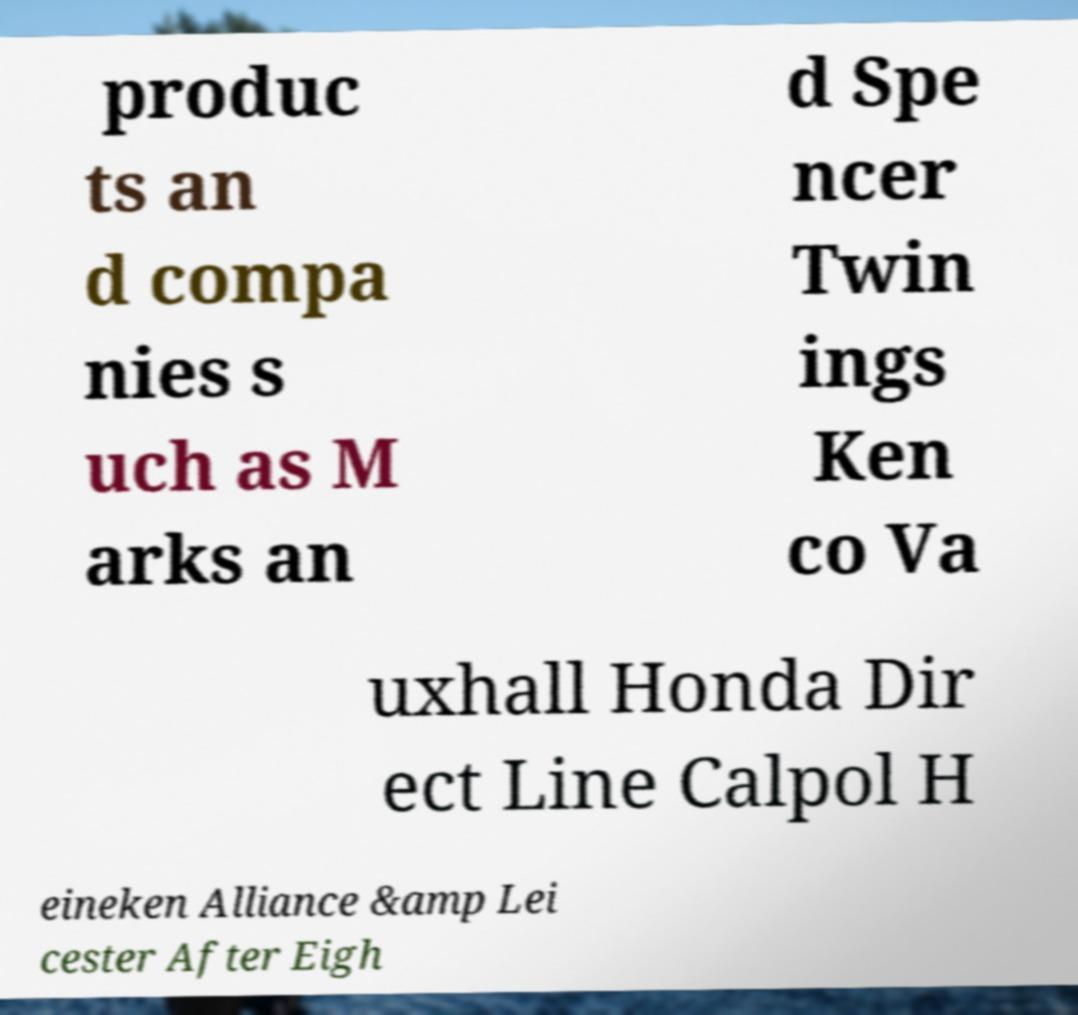Please read and relay the text visible in this image. What does it say? produc ts an d compa nies s uch as M arks an d Spe ncer Twin ings Ken co Va uxhall Honda Dir ect Line Calpol H eineken Alliance &amp Lei cester After Eigh 